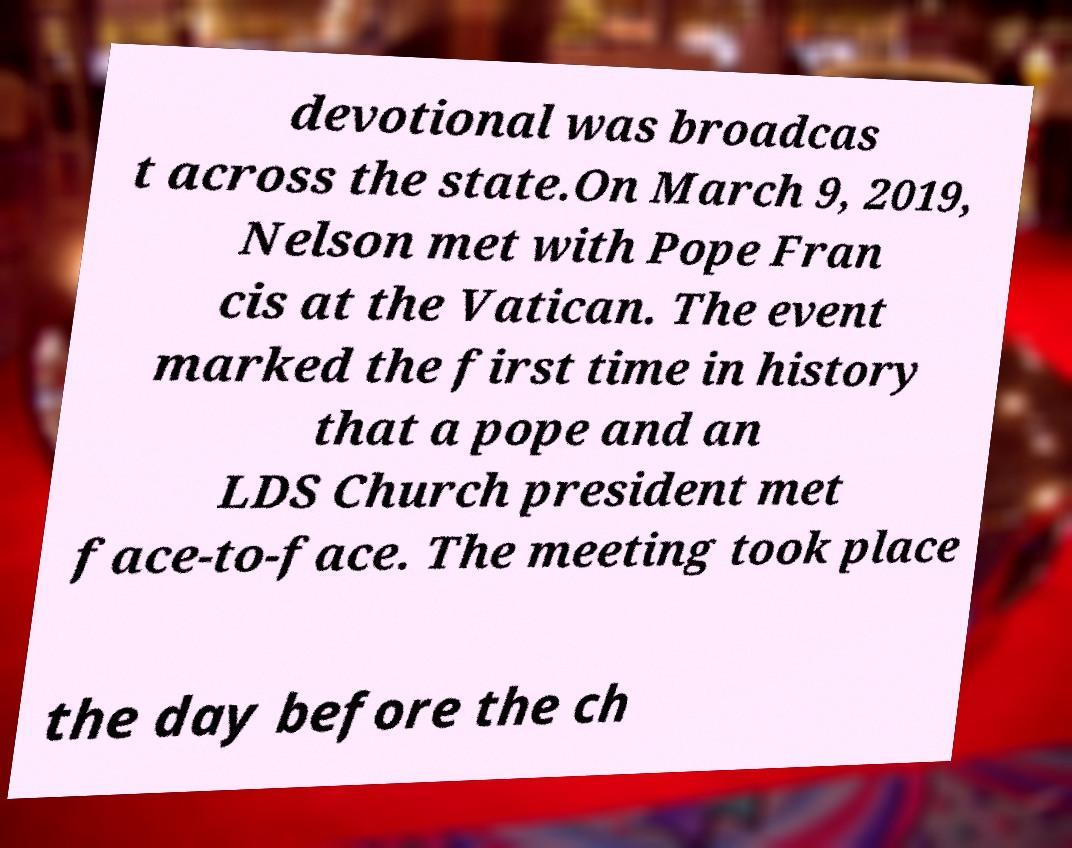Please identify and transcribe the text found in this image. devotional was broadcas t across the state.On March 9, 2019, Nelson met with Pope Fran cis at the Vatican. The event marked the first time in history that a pope and an LDS Church president met face-to-face. The meeting took place the day before the ch 